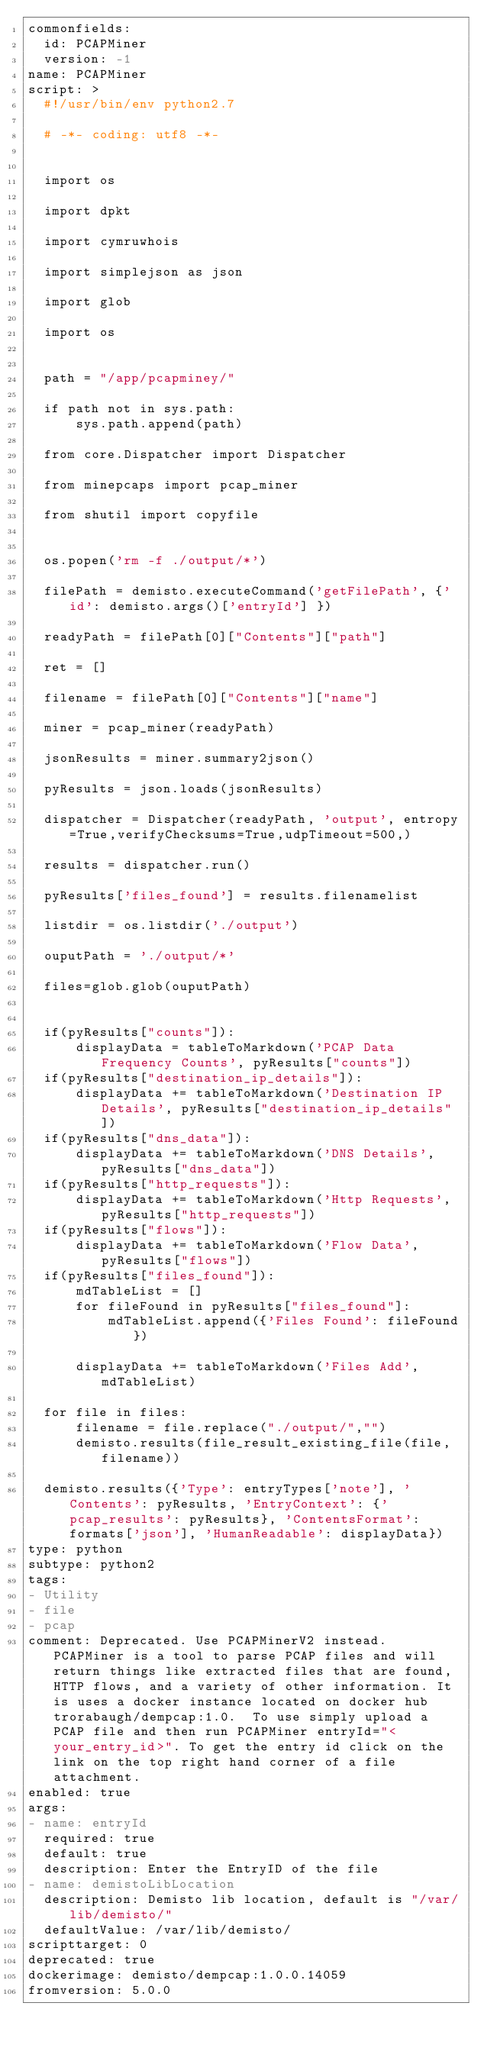Convert code to text. <code><loc_0><loc_0><loc_500><loc_500><_YAML_>commonfields:
  id: PCAPMiner
  version: -1
name: PCAPMiner
script: >
  #!/usr/bin/env python2.7

  # -*- coding: utf8 -*-


  import os

  import dpkt

  import cymruwhois

  import simplejson as json

  import glob

  import os


  path = "/app/pcapminey/"

  if path not in sys.path:
      sys.path.append(path)

  from core.Dispatcher import Dispatcher

  from minepcaps import pcap_miner

  from shutil import copyfile


  os.popen('rm -f ./output/*')

  filePath = demisto.executeCommand('getFilePath', {'id': demisto.args()['entryId'] })

  readyPath = filePath[0]["Contents"]["path"]

  ret = []

  filename = filePath[0]["Contents"]["name"]

  miner = pcap_miner(readyPath)

  jsonResults = miner.summary2json()

  pyResults = json.loads(jsonResults)

  dispatcher = Dispatcher(readyPath, 'output', entropy=True,verifyChecksums=True,udpTimeout=500,)

  results = dispatcher.run()

  pyResults['files_found'] = results.filenamelist

  listdir = os.listdir('./output')

  ouputPath = './output/*'

  files=glob.glob(ouputPath)


  if(pyResults["counts"]):
      displayData = tableToMarkdown('PCAP Data Frequency Counts', pyResults["counts"])
  if(pyResults["destination_ip_details"]):
      displayData += tableToMarkdown('Destination IP Details', pyResults["destination_ip_details"])
  if(pyResults["dns_data"]):
      displayData += tableToMarkdown('DNS Details', pyResults["dns_data"])
  if(pyResults["http_requests"]):
      displayData += tableToMarkdown('Http Requests', pyResults["http_requests"])
  if(pyResults["flows"]):
      displayData += tableToMarkdown('Flow Data', pyResults["flows"])
  if(pyResults["files_found"]):
      mdTableList = []
      for fileFound in pyResults["files_found"]:
          mdTableList.append({'Files Found': fileFound})

      displayData += tableToMarkdown('Files Add', mdTableList)

  for file in files:
      filename = file.replace("./output/","")
      demisto.results(file_result_existing_file(file, filename))

  demisto.results({'Type': entryTypes['note'], 'Contents': pyResults, 'EntryContext': {'pcap_results': pyResults}, 'ContentsFormat': formats['json'], 'HumanReadable': displayData})
type: python
subtype: python2
tags:
- Utility
- file
- pcap
comment: Deprecated. Use PCAPMinerV2 instead. PCAPMiner is a tool to parse PCAP files and will return things like extracted files that are found, HTTP flows, and a variety of other information. It is uses a docker instance located on docker hub trorabaugh/dempcap:1.0.  To use simply upload a PCAP file and then run PCAPMiner entryId="<your_entry_id>". To get the entry id click on the link on the top right hand corner of a file attachment.
enabled: true
args:
- name: entryId
  required: true
  default: true
  description: Enter the EntryID of the file
- name: demistoLibLocation
  description: Demisto lib location, default is "/var/lib/demisto/"
  defaultValue: /var/lib/demisto/
scripttarget: 0
deprecated: true
dockerimage: demisto/dempcap:1.0.0.14059
fromversion: 5.0.0
</code> 